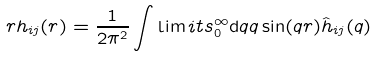Convert formula to latex. <formula><loc_0><loc_0><loc_500><loc_500>r h _ { i j } ( r ) = \frac { 1 } { 2 \pi ^ { 2 } } \int \lim i t s _ { 0 } ^ { \infty } { \mathrm d } q q \sin ( q r ) \hat { h } _ { i j } ( q )</formula> 